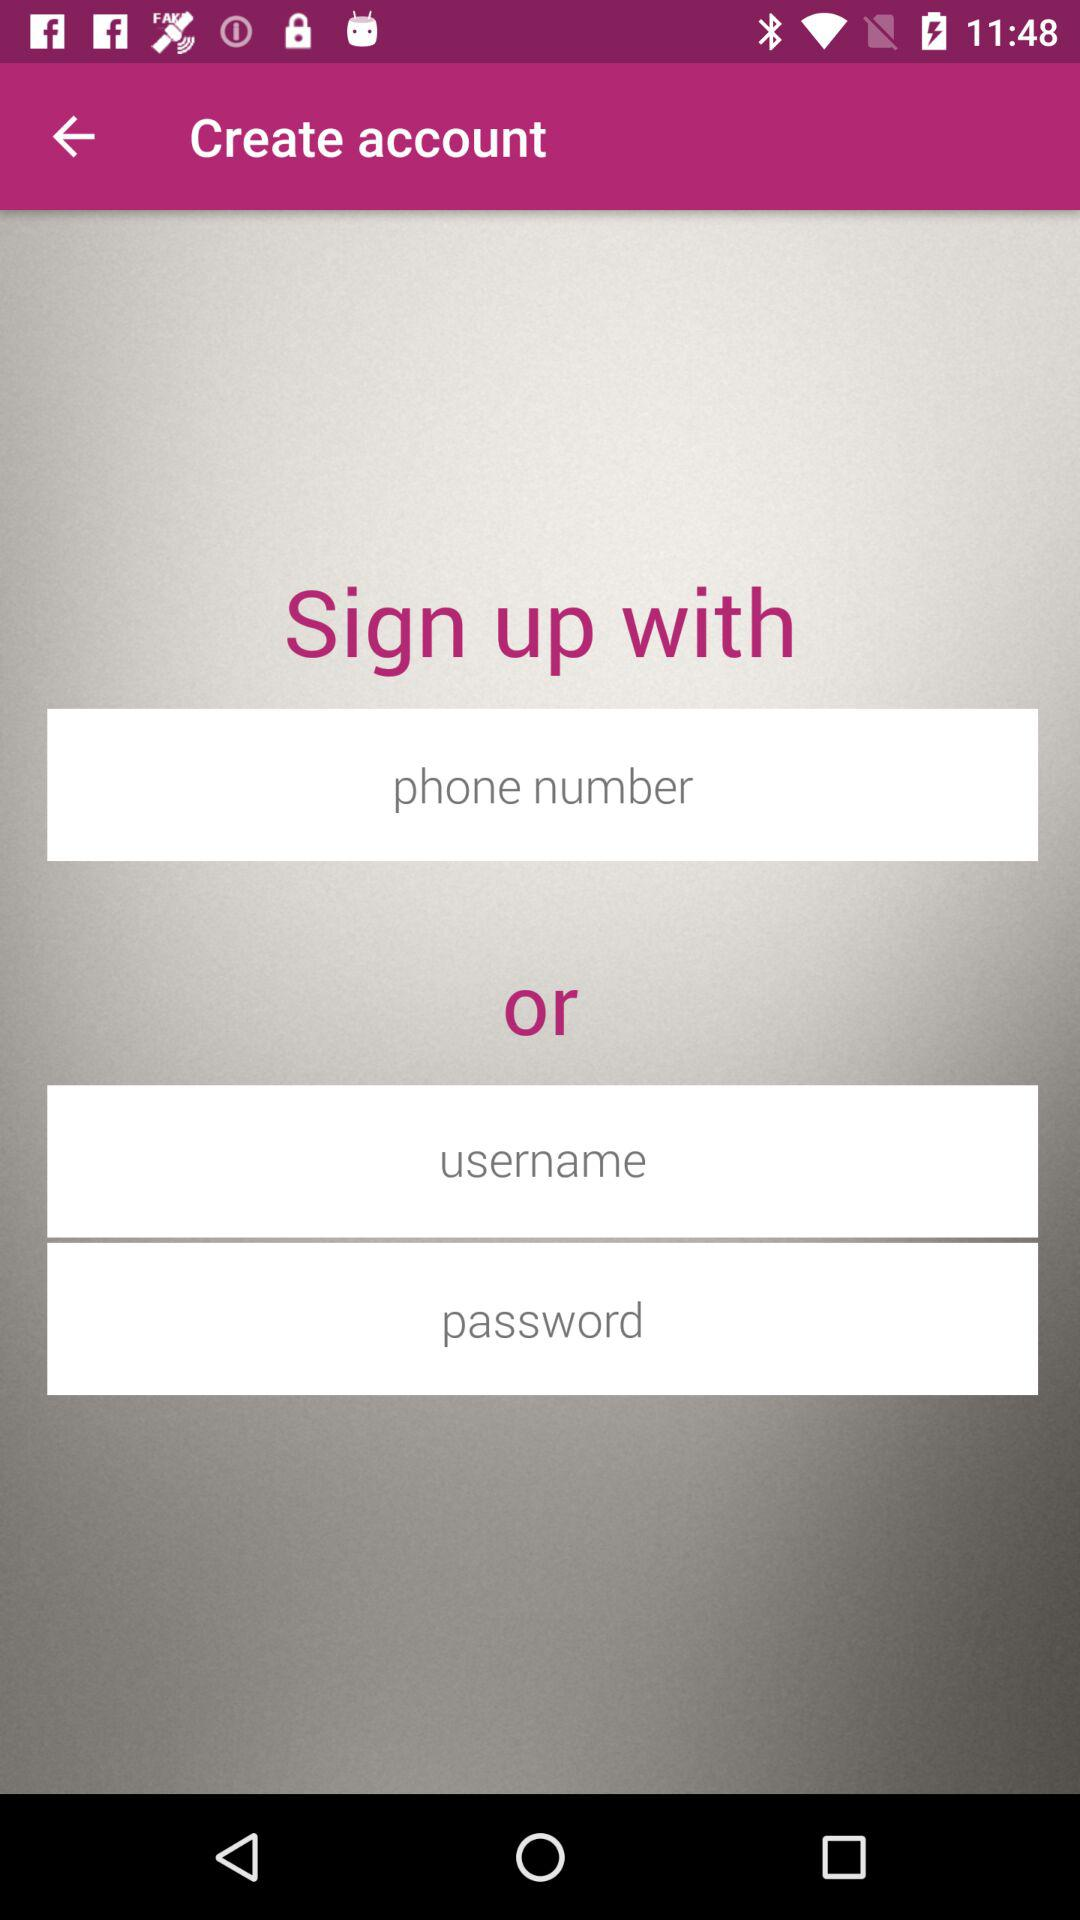What are the requirements to sign up? The requirements to sign up are "phone number", "username" and "password". 